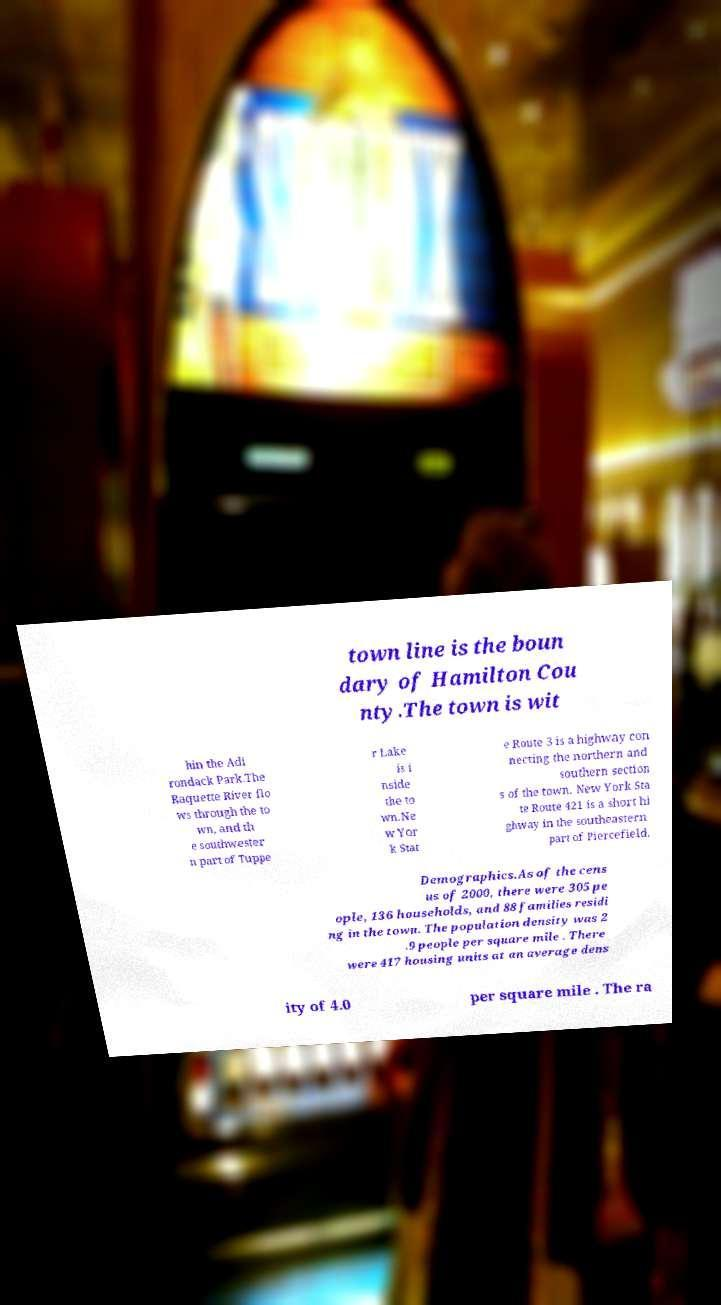Can you accurately transcribe the text from the provided image for me? town line is the boun dary of Hamilton Cou nty.The town is wit hin the Adi rondack Park.The Raquette River flo ws through the to wn, and th e southwester n part of Tuppe r Lake is i nside the to wn.Ne w Yor k Stat e Route 3 is a highway con necting the northern and southern section s of the town. New York Sta te Route 421 is a short hi ghway in the southeastern part of Piercefield. Demographics.As of the cens us of 2000, there were 305 pe ople, 136 households, and 88 families residi ng in the town. The population density was 2 .9 people per square mile . There were 417 housing units at an average dens ity of 4.0 per square mile . The ra 